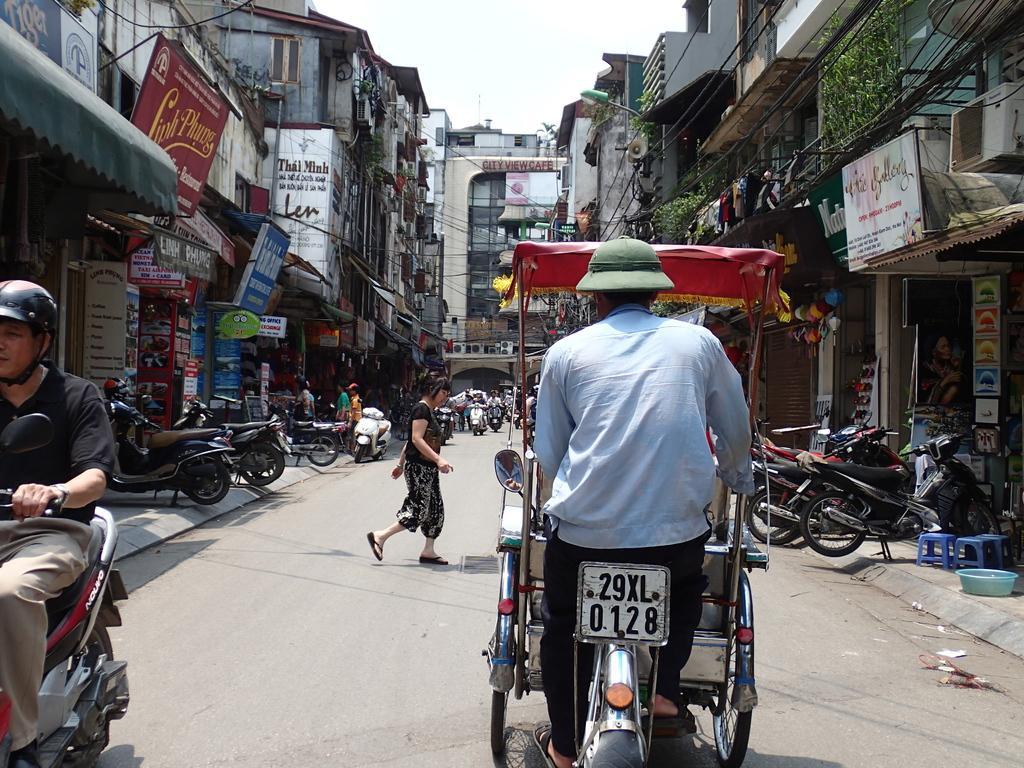In one or two sentences, can you explain what this image depicts? This is a street. On the street a person is riding a vehicle. And he is wearing a hat. Another person on the left side is riding a scooter wearing a helmet. A lady is crossing the road. There are bikes parked on the sides of the road. There are many shops on the sides. There are banners on the roads. In the background there are buildings. 